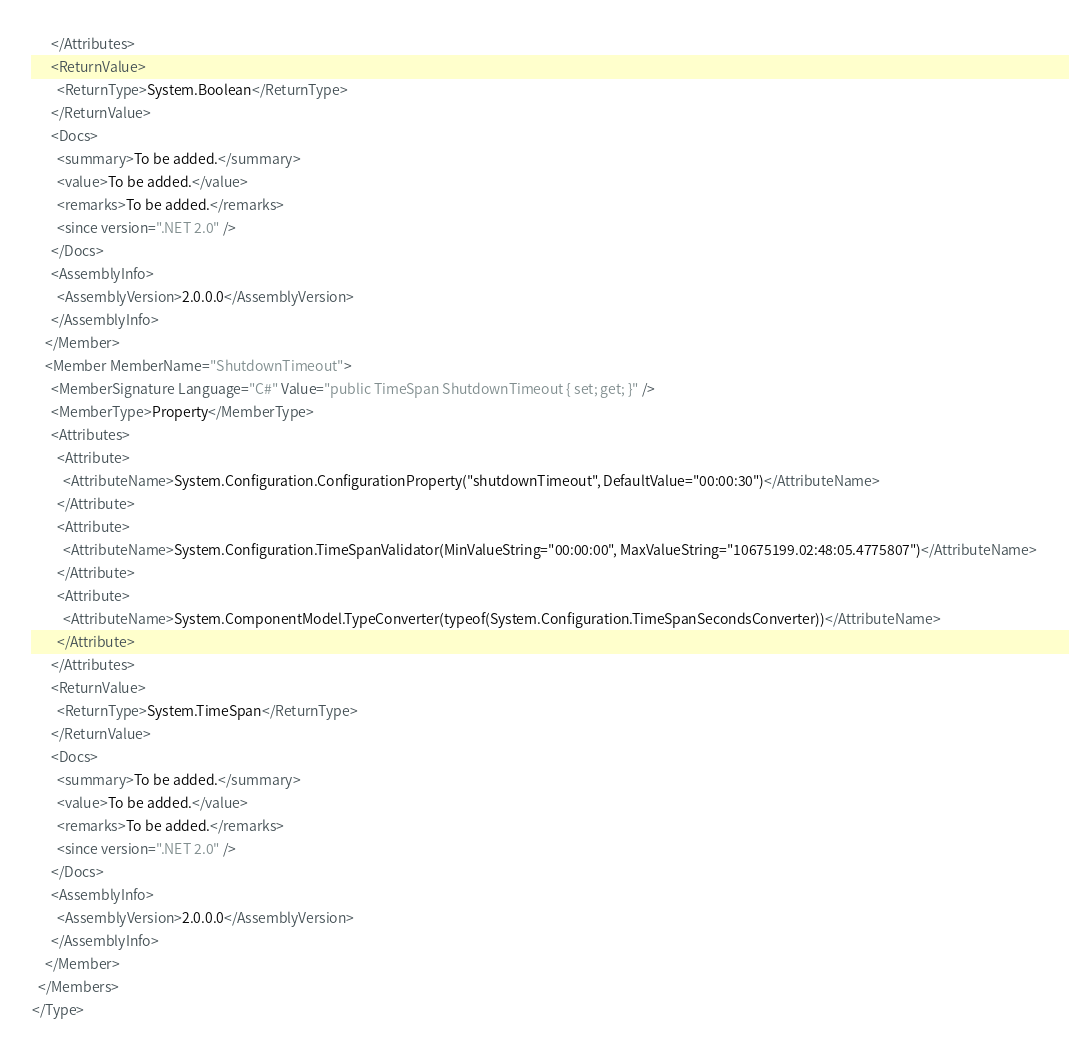Convert code to text. <code><loc_0><loc_0><loc_500><loc_500><_XML_>      </Attributes>
      <ReturnValue>
        <ReturnType>System.Boolean</ReturnType>
      </ReturnValue>
      <Docs>
        <summary>To be added.</summary>
        <value>To be added.</value>
        <remarks>To be added.</remarks>
        <since version=".NET 2.0" />
      </Docs>
      <AssemblyInfo>
        <AssemblyVersion>2.0.0.0</AssemblyVersion>
      </AssemblyInfo>
    </Member>
    <Member MemberName="ShutdownTimeout">
      <MemberSignature Language="C#" Value="public TimeSpan ShutdownTimeout { set; get; }" />
      <MemberType>Property</MemberType>
      <Attributes>
        <Attribute>
          <AttributeName>System.Configuration.ConfigurationProperty("shutdownTimeout", DefaultValue="00:00:30")</AttributeName>
        </Attribute>
        <Attribute>
          <AttributeName>System.Configuration.TimeSpanValidator(MinValueString="00:00:00", MaxValueString="10675199.02:48:05.4775807")</AttributeName>
        </Attribute>
        <Attribute>
          <AttributeName>System.ComponentModel.TypeConverter(typeof(System.Configuration.TimeSpanSecondsConverter))</AttributeName>
        </Attribute>
      </Attributes>
      <ReturnValue>
        <ReturnType>System.TimeSpan</ReturnType>
      </ReturnValue>
      <Docs>
        <summary>To be added.</summary>
        <value>To be added.</value>
        <remarks>To be added.</remarks>
        <since version=".NET 2.0" />
      </Docs>
      <AssemblyInfo>
        <AssemblyVersion>2.0.0.0</AssemblyVersion>
      </AssemblyInfo>
    </Member>
  </Members>
</Type>
</code> 